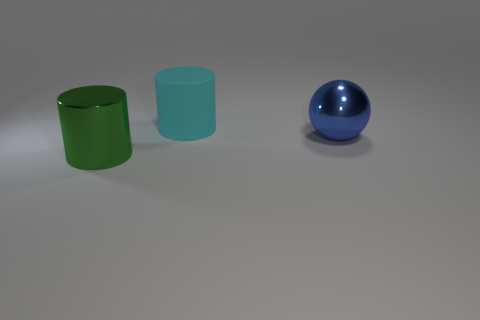Is the number of blue things greater than the number of tiny gray cylinders?
Your answer should be compact. Yes. There is a metal object to the left of the big object that is right of the cylinder that is to the right of the green cylinder; what color is it?
Your response must be concise. Green. What is the color of the cylinder that is made of the same material as the big sphere?
Your response must be concise. Green. What number of objects are shiny things right of the cyan cylinder or balls to the right of the matte thing?
Ensure brevity in your answer.  1. The other large object that is the same shape as the green object is what color?
Make the answer very short. Cyan. Is there anything else that has the same shape as the blue metal object?
Ensure brevity in your answer.  No. Is the number of big blue shiny things that are in front of the cyan matte cylinder greater than the number of rubber cylinders on the right side of the large green metallic cylinder?
Offer a terse response. No. Do the large blue sphere and the cylinder behind the large green cylinder have the same material?
Your response must be concise. No. Is the shape of the cyan object the same as the green object?
Make the answer very short. Yes. What number of other objects are the same material as the large cyan thing?
Provide a succinct answer. 0. 